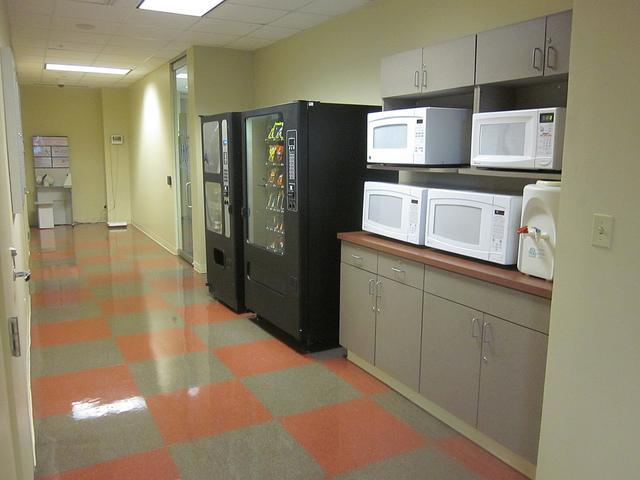How many people can cook food here at once? Please explain your reasoning. four. There are four microwaves on the counter. 